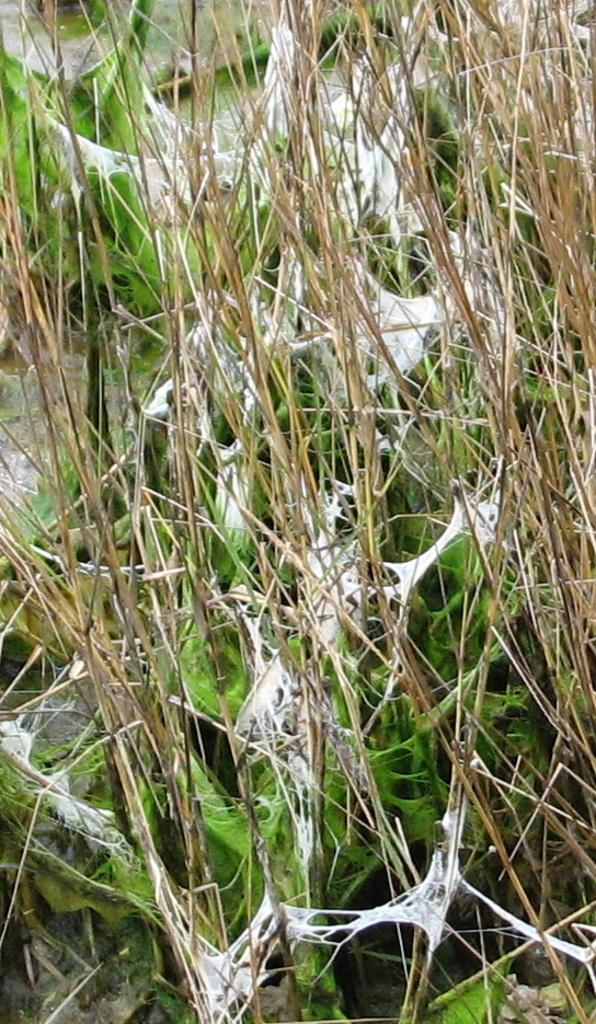What type of vegetation can be seen in the image? There is grass in the image. What other natural element can be seen in the image? There is fungus in the image. What type of ring can be seen on the fungus in the image? There is no ring present on the fungus in the image. What tool is being used to hammer the grass in the image? There is no tool or hammering action depicted in the image; it only shows grass and fungus. 